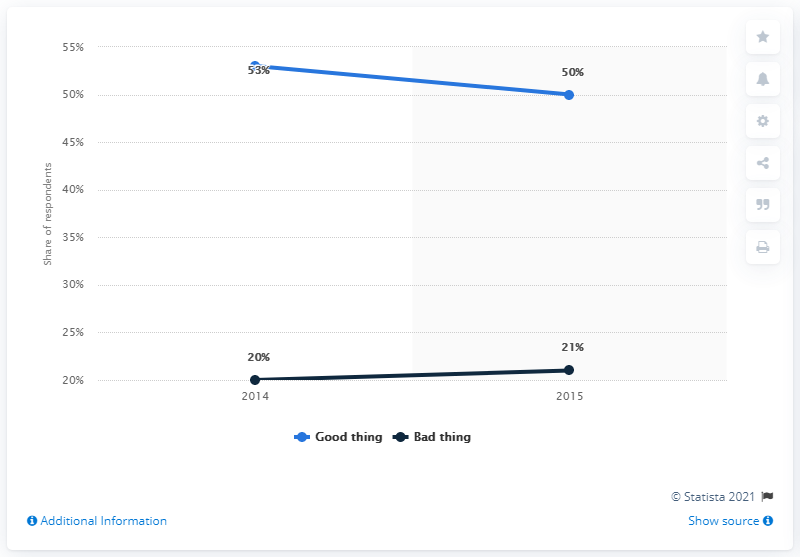Highlight a few significant elements in this photo. In 2015, 50% of Americans believed that the Transatlantic Trade and Investment Partnership (TTIP) would be beneficial for the United States. 